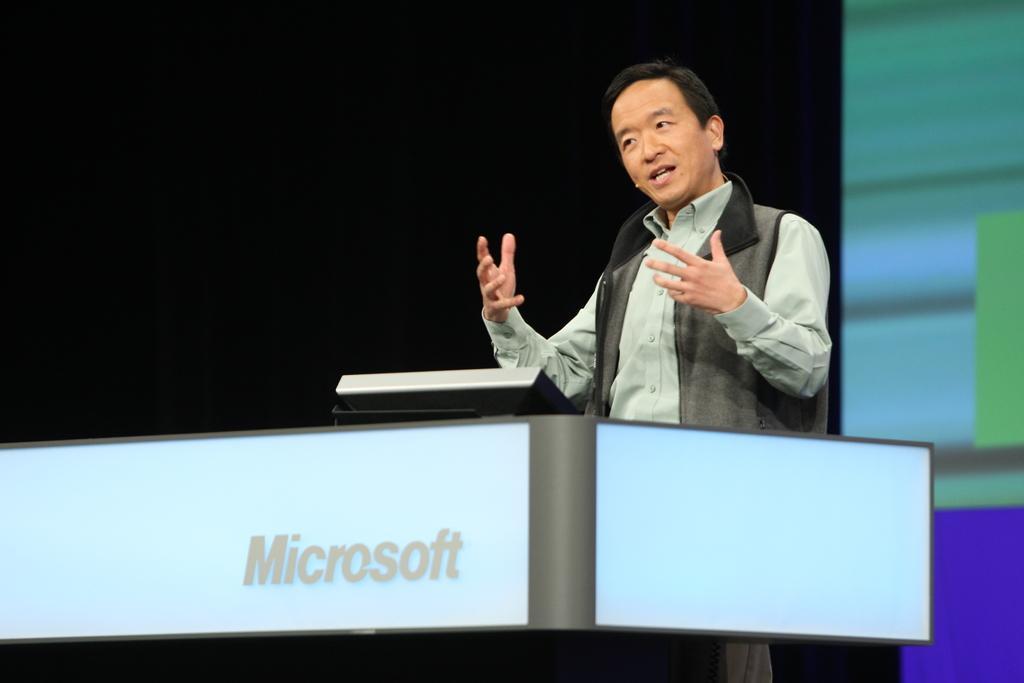Can you describe this image briefly? In this picture I can see a man standing near the podium. I can see a screen, and there is dark background. 